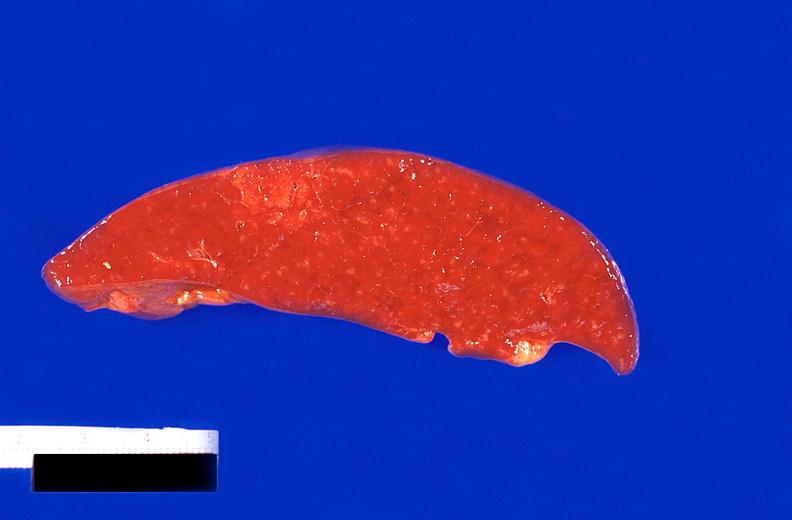does anencephaly show spleen, infarcts, thrombotic thrombocytopenic purpura?
Answer the question using a single word or phrase. No 